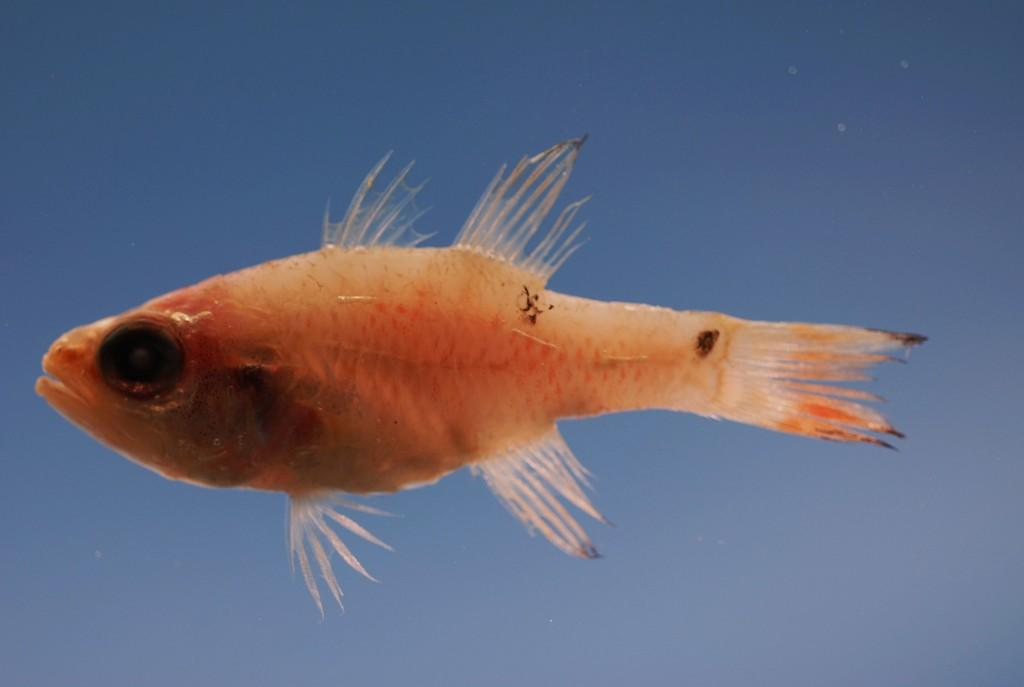What is the main subject of the image? The main subject of the image is a fish. Where is the fish located? The fish is in water. Can we determine the specific type of water the fish is in? Based on the provided facts, we cannot confirm whether the water is in an ocean or another body of water. How many wrens are swimming alongside the fish in the image? There are no wrens present in the image; it features a fish in water. What type of snakes can be seen interacting with the fish in the image? There are no snakes present in the image; it features a fish in water. 